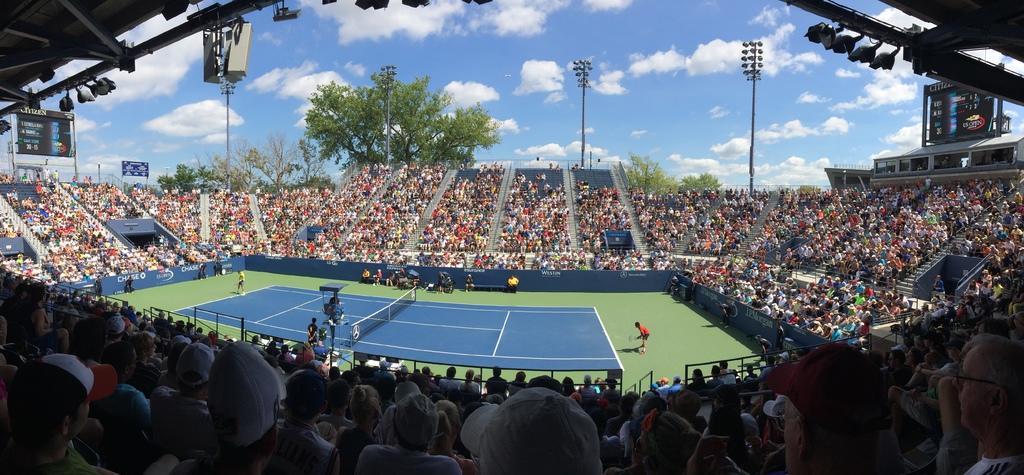Describe this image in one or two sentences. In this picture I can see a stadium and I see number of people. In the background I see the trees and the sky and I see number of light poles. 